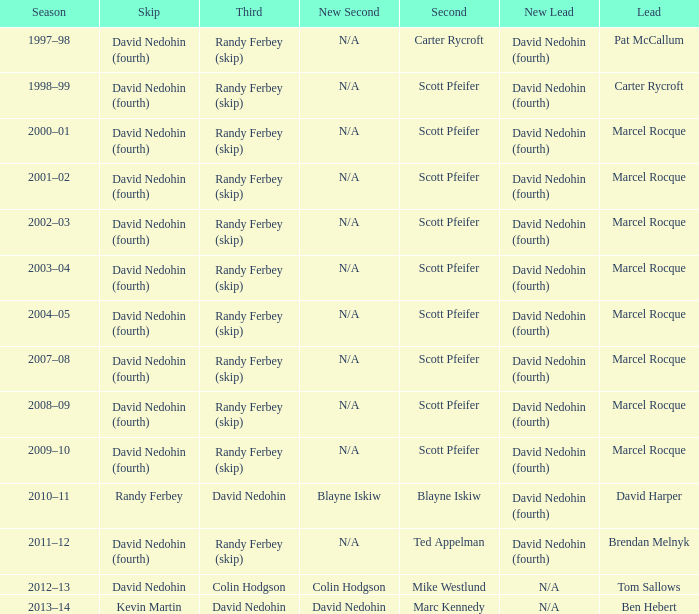Which Season has a Third of colin hodgson? 2012–13. 